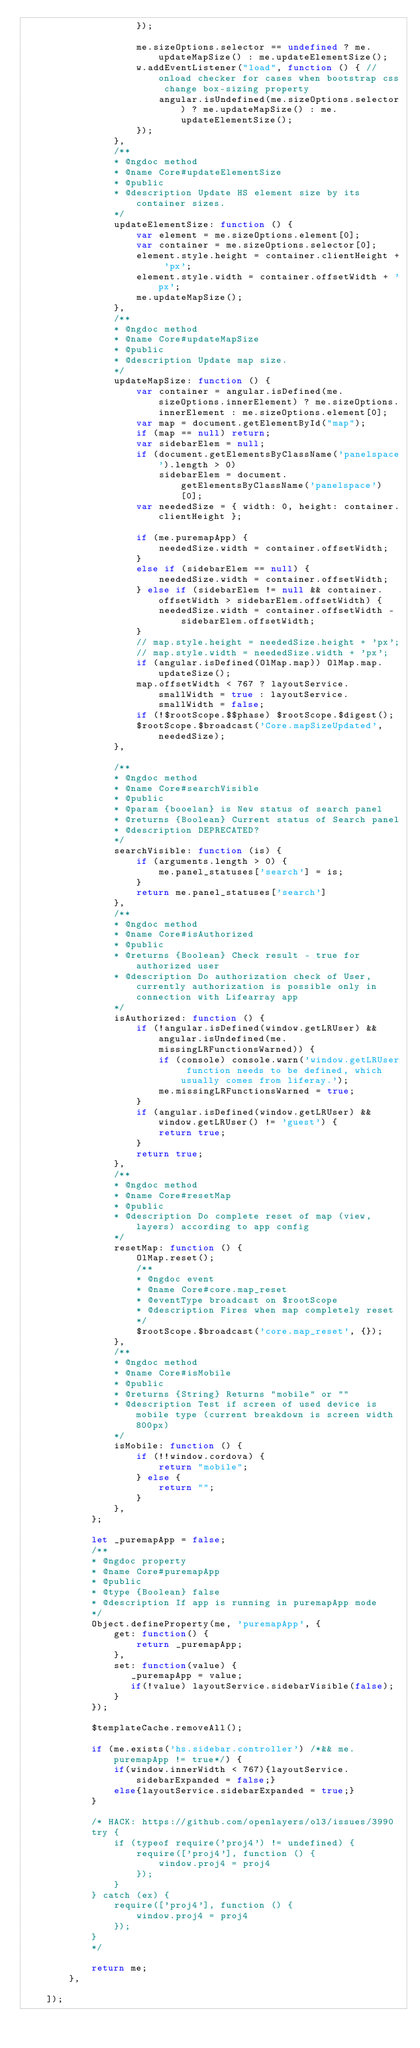Convert code to text. <code><loc_0><loc_0><loc_500><loc_500><_JavaScript_>                    });
                    
                    me.sizeOptions.selector == undefined ? me.updateMapSize() : me.updateElementSize();
                    w.addEventListener("load", function () { //onload checker for cases when bootstrap css change box-sizing property
                        angular.isUndefined(me.sizeOptions.selector) ? me.updateMapSize() : me.updateElementSize();
                    });
                },
                /**
                * @ngdoc method
                * @name Core#updateElementSize
                * @public
                * @description Update HS element size by its container sizes.
                */
                updateElementSize: function () {
                    var element = me.sizeOptions.element[0];
                    var container = me.sizeOptions.selector[0];
                    element.style.height = container.clientHeight + 'px';
                    element.style.width = container.offsetWidth + 'px';
                    me.updateMapSize();
                },
                /**
                * @ngdoc method
                * @name Core#updateMapSize
                * @public
                * @description Update map size.
                */
                updateMapSize: function () {
                    var container = angular.isDefined(me.sizeOptions.innerElement) ? me.sizeOptions.innerElement : me.sizeOptions.element[0];
                    var map = document.getElementById("map");
                    if (map == null) return;
                    var sidebarElem = null;
                    if (document.getElementsByClassName('panelspace').length > 0)
                        sidebarElem = document.getElementsByClassName('panelspace')[0];
                    var neededSize = { width: 0, height: container.clientHeight };

                    if (me.puremapApp) {
                        neededSize.width = container.offsetWidth;
                    }
                    else if (sidebarElem == null) {
                        neededSize.width = container.offsetWidth;
                    } else if (sidebarElem != null && container.offsetWidth > sidebarElem.offsetWidth) {
                        neededSize.width = container.offsetWidth - sidebarElem.offsetWidth;
                    }
                    // map.style.height = neededSize.height + 'px';
                    // map.style.width = neededSize.width + 'px';
                    if (angular.isDefined(OlMap.map)) OlMap.map.updateSize();
                    map.offsetWidth < 767 ? layoutService.smallWidth = true : layoutService.smallWidth = false;
                    if (!$rootScope.$$phase) $rootScope.$digest();
                    $rootScope.$broadcast('Core.mapSizeUpdated', neededSize);
                },

                /**
                * @ngdoc method
                * @name Core#searchVisible 
                * @public
                * @param {booelan} is New status of search panel
                * @returns {Boolean} Current status of Search panel
                * @description DEPRECATED?
                */
                searchVisible: function (is) {
                    if (arguments.length > 0) {
                        me.panel_statuses['search'] = is;
                    }
                    return me.panel_statuses['search']
                },
                /**
                * @ngdoc method
                * @name Core#isAuthorized 
                * @public
                * @returns {Boolean} Check result - true for authorized user
                * @description Do authorization check of User, currently authorization is possible only in connection with Lifearray app
                */
                isAuthorized: function () {
                    if (!angular.isDefined(window.getLRUser) && angular.isUndefined(me.missingLRFunctionsWarned)) {
                        if (console) console.warn('window.getLRUser function needs to be defined, which usually comes from liferay.');
                        me.missingLRFunctionsWarned = true;
                    }
                    if (angular.isDefined(window.getLRUser) && window.getLRUser() != 'guest') {
                        return true;
                    }
                    return true;
                },
                /**
                * @ngdoc method
                * @name Core#resetMap
                * @public
                * @description Do complete reset of map (view, layers) according to app config
                */
                resetMap: function () {
                    OlMap.reset();
                    /**
                    * @ngdoc event
                    * @name Core#core.map_reset
                    * @eventType broadcast on $rootScope
                    * @description Fires when map completely reset
                    */
                    $rootScope.$broadcast('core.map_reset', {});
                },
                /**
                * @ngdoc method
                * @name Core#isMobile 
                * @public
                * @returns {String} Returns "mobile" or ""
                * @description Test if screen of used device is mobile type (current breakdown is screen width 800px)
                */
                isMobile: function () {
                    if (!!window.cordova) {
                        return "mobile";
                    } else {
                        return "";
                    }
                },
            };

            let _puremapApp = false;
            /**
            * @ngdoc property
            * @name Core#puremapApp
            * @public
            * @type {Boolean} false 
            * @description If app is running in puremapApp mode
            */
            Object.defineProperty(me, 'puremapApp', {
                get: function() {
                    return _puremapApp;
                },
                set: function(value) {
                   _puremapApp = value;
                   if(!value) layoutService.sidebarVisible(false);
                }
            });

            $templateCache.removeAll();

            if (me.exists('hs.sidebar.controller') /*&& me.puremapApp != true*/) {
                if(window.innerWidth < 767){layoutService.sidebarExpanded = false;}
                else{layoutService.sidebarExpanded = true;}
            }

            /* HACK: https://github.com/openlayers/ol3/issues/3990 
            try {
                if (typeof require('proj4') != undefined) {
                    require(['proj4'], function () {
                        window.proj4 = proj4
                    });
                }
            } catch (ex) {
                require(['proj4'], function () {
                    window.proj4 = proj4
                });
            }
            */

            return me;
        },

    ]);
</code> 